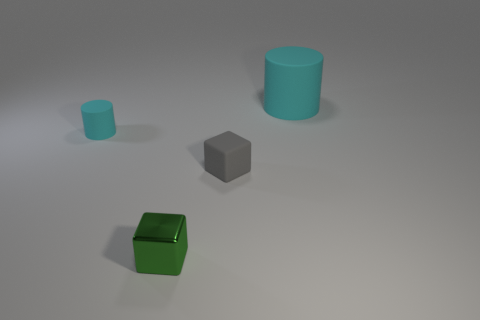What material is the thing that is on the left side of the gray rubber object and in front of the tiny rubber cylinder?
Ensure brevity in your answer.  Metal. There is a block on the right side of the tiny green shiny thing; what is it made of?
Your response must be concise. Rubber. What color is the tiny cylinder that is the same material as the big cylinder?
Offer a very short reply. Cyan. There is a big cyan rubber thing; is it the same shape as the tiny object that is behind the small gray matte block?
Provide a short and direct response. Yes. There is a gray matte thing; are there any tiny cubes on the left side of it?
Provide a short and direct response. Yes. There is a thing that is the same color as the big cylinder; what material is it?
Make the answer very short. Rubber. Is the size of the gray object the same as the object on the right side of the small gray matte thing?
Your answer should be very brief. No. Is there a tiny cylinder of the same color as the big cylinder?
Offer a very short reply. Yes. Is there a small blue thing that has the same shape as the large cyan rubber object?
Your answer should be very brief. No. The thing that is on the left side of the tiny gray cube and behind the green metallic thing has what shape?
Your answer should be very brief. Cylinder. 